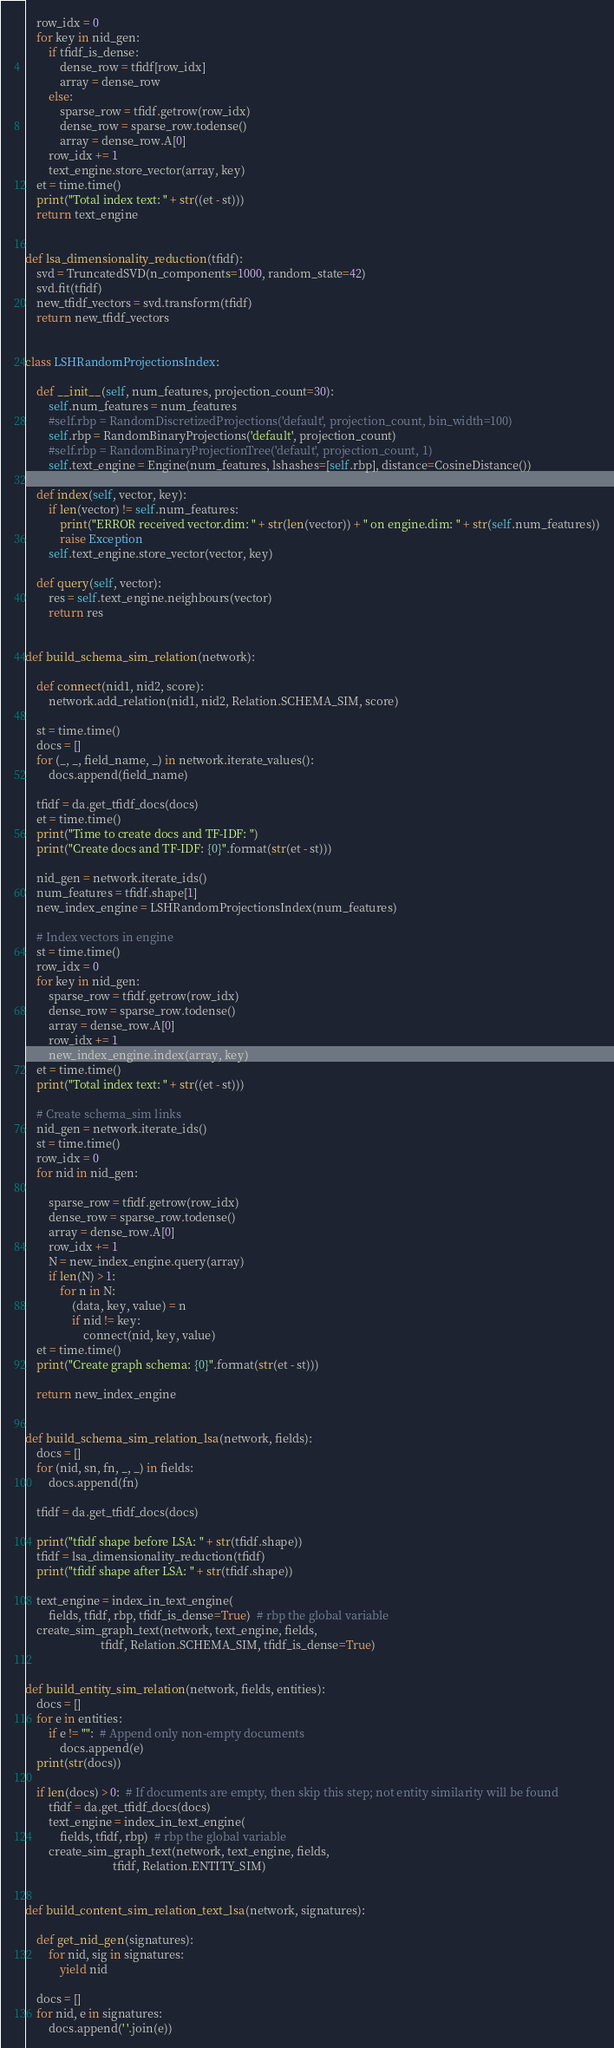Convert code to text. <code><loc_0><loc_0><loc_500><loc_500><_Python_>    row_idx = 0
    for key in nid_gen:
        if tfidf_is_dense:
            dense_row = tfidf[row_idx]
            array = dense_row
        else:
            sparse_row = tfidf.getrow(row_idx)
            dense_row = sparse_row.todense()
            array = dense_row.A[0]
        row_idx += 1
        text_engine.store_vector(array, key)
    et = time.time()
    print("Total index text: " + str((et - st)))
    return text_engine


def lsa_dimensionality_reduction(tfidf):
    svd = TruncatedSVD(n_components=1000, random_state=42)
    svd.fit(tfidf)
    new_tfidf_vectors = svd.transform(tfidf)
    return new_tfidf_vectors


class LSHRandomProjectionsIndex:

    def __init__(self, num_features, projection_count=30):
        self.num_features = num_features
        #self.rbp = RandomDiscretizedProjections('default', projection_count, bin_width=100)
        self.rbp = RandomBinaryProjections('default', projection_count)
        #self.rbp = RandomBinaryProjectionTree('default', projection_count, 1)
        self.text_engine = Engine(num_features, lshashes=[self.rbp], distance=CosineDistance())

    def index(self, vector, key):
        if len(vector) != self.num_features:
            print("ERROR received vector.dim: " + str(len(vector)) + " on engine.dim: " + str(self.num_features))
            raise Exception
        self.text_engine.store_vector(vector, key)

    def query(self, vector):
        res = self.text_engine.neighbours(vector)
        return res


def build_schema_sim_relation(network):

    def connect(nid1, nid2, score):
        network.add_relation(nid1, nid2, Relation.SCHEMA_SIM, score)

    st = time.time()
    docs = []
    for (_, _, field_name, _) in network.iterate_values():
        docs.append(field_name)

    tfidf = da.get_tfidf_docs(docs)
    et = time.time()
    print("Time to create docs and TF-IDF: ")
    print("Create docs and TF-IDF: {0}".format(str(et - st)))

    nid_gen = network.iterate_ids()
    num_features = tfidf.shape[1]
    new_index_engine = LSHRandomProjectionsIndex(num_features)

    # Index vectors in engine
    st = time.time()
    row_idx = 0
    for key in nid_gen:
        sparse_row = tfidf.getrow(row_idx)
        dense_row = sparse_row.todense()
        array = dense_row.A[0]
        row_idx += 1
        new_index_engine.index(array, key)
    et = time.time()
    print("Total index text: " + str((et - st)))

    # Create schema_sim links
    nid_gen = network.iterate_ids()
    st = time.time()
    row_idx = 0
    for nid in nid_gen:

        sparse_row = tfidf.getrow(row_idx)
        dense_row = sparse_row.todense()
        array = dense_row.A[0]
        row_idx += 1
        N = new_index_engine.query(array)
        if len(N) > 1:
            for n in N:
                (data, key, value) = n
                if nid != key:
                    connect(nid, key, value)
    et = time.time()
    print("Create graph schema: {0}".format(str(et - st)))

    return new_index_engine


def build_schema_sim_relation_lsa(network, fields):
    docs = []
    for (nid, sn, fn, _, _) in fields:
        docs.append(fn)

    tfidf = da.get_tfidf_docs(docs)

    print("tfidf shape before LSA: " + str(tfidf.shape))
    tfidf = lsa_dimensionality_reduction(tfidf)
    print("tfidf shape after LSA: " + str(tfidf.shape))

    text_engine = index_in_text_engine(
        fields, tfidf, rbp, tfidf_is_dense=True)  # rbp the global variable
    create_sim_graph_text(network, text_engine, fields,
                          tfidf, Relation.SCHEMA_SIM, tfidf_is_dense=True)


def build_entity_sim_relation(network, fields, entities):
    docs = []
    for e in entities:
        if e != "":  # Append only non-empty documents
            docs.append(e)
    print(str(docs))

    if len(docs) > 0:  # If documents are empty, then skip this step; not entity similarity will be found
        tfidf = da.get_tfidf_docs(docs)
        text_engine = index_in_text_engine(
            fields, tfidf, rbp)  # rbp the global variable
        create_sim_graph_text(network, text_engine, fields,
                              tfidf, Relation.ENTITY_SIM)


def build_content_sim_relation_text_lsa(network, signatures):

    def get_nid_gen(signatures):
        for nid, sig in signatures:
            yield nid

    docs = []
    for nid, e in signatures:
        docs.append(' '.join(e))
</code> 